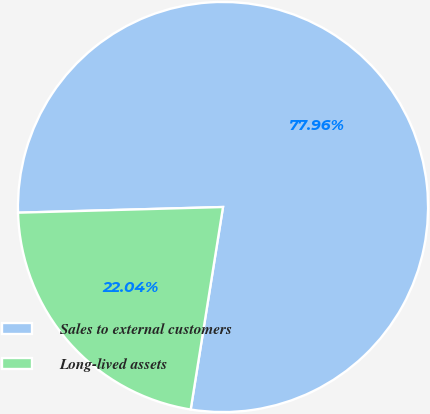<chart> <loc_0><loc_0><loc_500><loc_500><pie_chart><fcel>Sales to external customers<fcel>Long-lived assets<nl><fcel>77.96%<fcel>22.04%<nl></chart> 